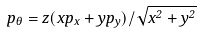Convert formula to latex. <formula><loc_0><loc_0><loc_500><loc_500>p _ { \theta } = z ( x p _ { x } + y p _ { y } ) / \sqrt { x ^ { 2 } + y ^ { 2 } }</formula> 